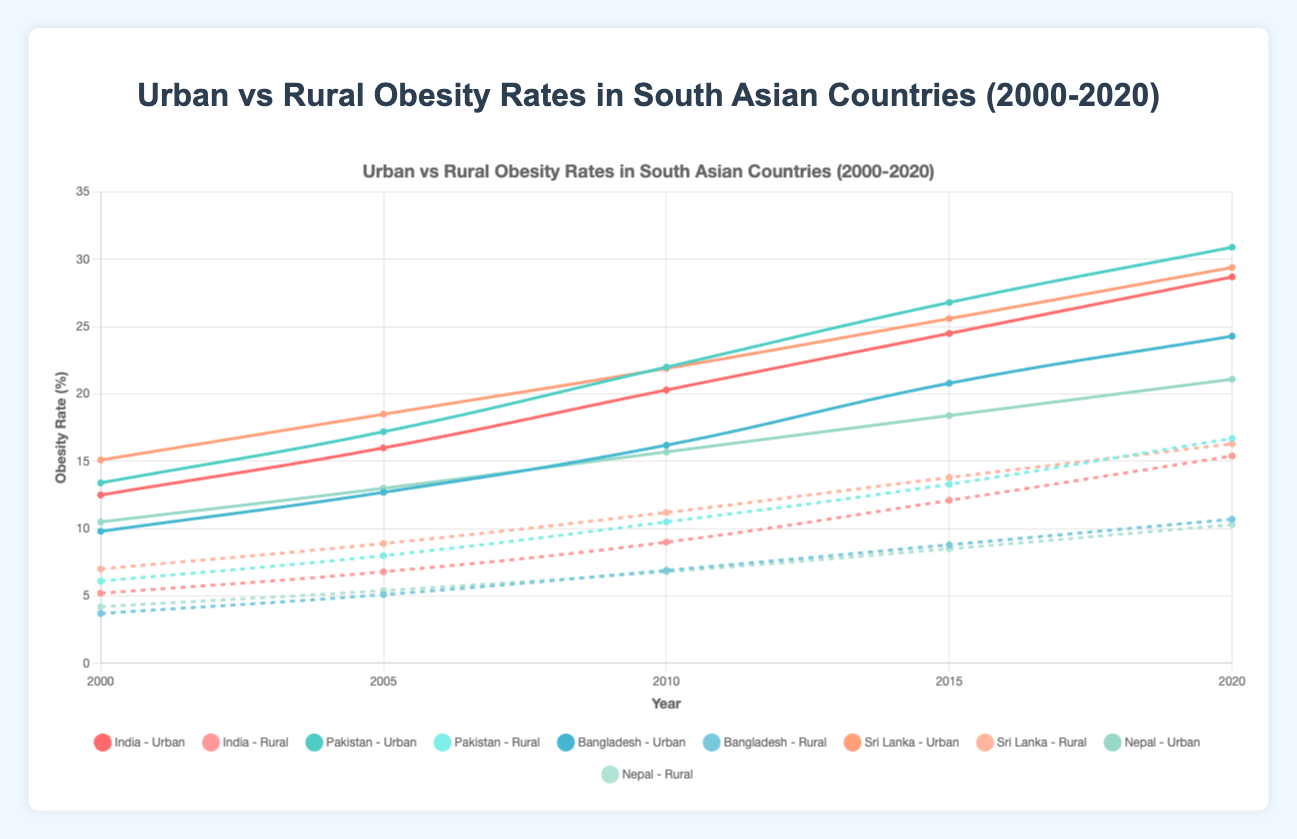What is the trend in urban obesity rates in India from 2000 to 2020? The urban obesity rate in India increases consistently over time: from 12.5% in 2000, to 16.0% in 2005, 20.3% in 2010, 24.5% in 2015, and 28.7% in 2020.
Answer: Consistent increase Which country had the highest rural obesity rate in 2020? In 2020, we compare the rural obesity rates of all countries. Sri Lanka had the highest rural obesity rate at 16.3%.
Answer: Sri Lanka How much did the urban obesity rate increase in Pakistan from 2000 to 2020? The urban obesity rate in Pakistan increased from 13.4% in 2000 to 30.9% in 2020. The increase is 30.9 - 13.4 = 17.5%.
Answer: 17.5% Which country showed the greatest difference between urban and rural obesity rates in 2010? In 2010, we calculate the difference for each country:
- India: 20.3 - 9.0 = 11.3
- Pakistan: 22.0 - 10.5 = 11.5
- Bangladesh: 16.2 - 6.9 = 9.3
- Sri Lanka: 21.9 - 11.2 = 10.7
- Nepal: 15.7 - 6.8 = 8.9
Therefore, Pakistan exhibited the greatest difference of 11.5%.
Answer: Pakistan Which country had the lowest urban obesity rate in 2000, and what was it? In 2000, comparing urban obesity rates gives Bangladesh the lowest rate at 9.8%.
Answer: Bangladesh: 9.8% Compare the rural obesity rate trends of Bangladesh and Nepal from 2000 to 2020. For Bangladesh, rural obesity rates were: 3.7% (2000), 5.1% (2005), 6.9% (2010), 8.8% (2015), and 10.7% (2020). For Nepal, they were: 4.2% (2000), 5.4% (2005), 6.8% (2010), 8.5% (2015), and 10.3% (2020). Both countries showed an increasing trend.
Answer: Both increasing How significant was the disparity between urban and rural obesity rates in Sri Lanka in 2005? In 2005, the disparity in obesity rates in Sri Lanka was calculated by subtracting the rural rate from the urban rate: 18.5 - 8.9 = 9.6%.
Answer: 9.6% What visual differences denote urban and rural obesity rates on the plot? Urban obesity rates are denoted using solid lines, whereas rural obesity rates are shown with dashed lines. Additionally, urban lines are generally higher on the y-axis compared to rural lines.
Answer: Solid vs. dashed lines; higher y-axis position What is the average urban obesity rate in Nepal across all years shown? Summing the urban obesity rates for Nepal (10.5 + 13.0 + 15.7 + 18.4 + 21.1) equals 78.7, and dividing by 5 gives an average of 78.7 / 5 = 15.74%.
Answer: 15.74% Was there any year where Bangladesh's rural obesity rate equaled Pakistan's rural obesity rate? Checking year-wise values, no year showed an equal rural obesity rate between Bangladesh (3.7%, 5.1%, 6.9%, 8.8%, 10.7%) and Pakistan (6.1%, 8.0%, 10.5%, 13.3%, 16.7%).
Answer: No 